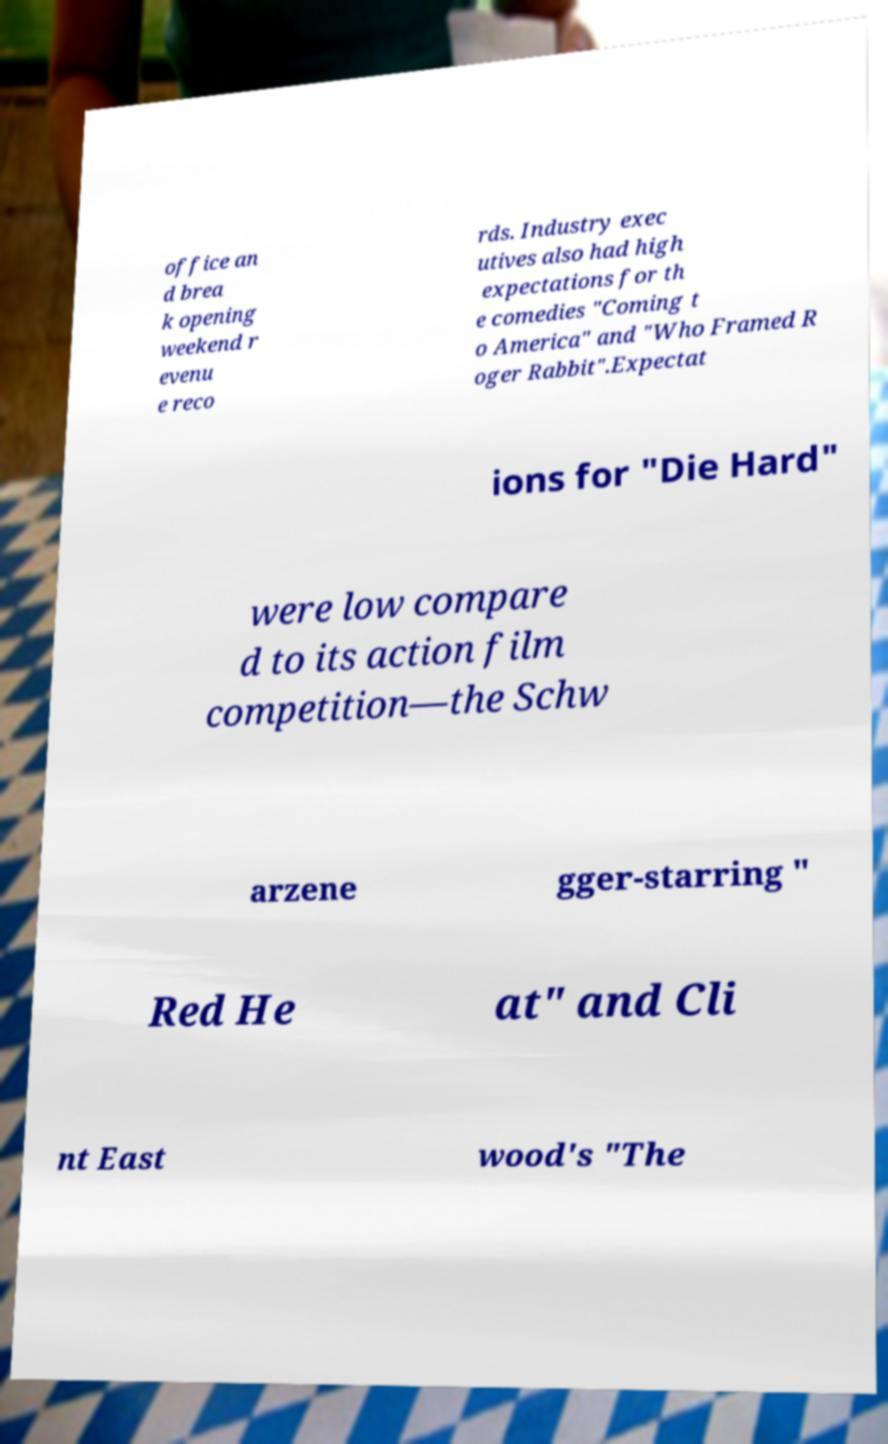What messages or text are displayed in this image? I need them in a readable, typed format. office an d brea k opening weekend r evenu e reco rds. Industry exec utives also had high expectations for th e comedies "Coming t o America" and "Who Framed R oger Rabbit".Expectat ions for "Die Hard" were low compare d to its action film competition—the Schw arzene gger-starring " Red He at" and Cli nt East wood's "The 